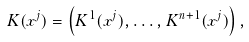<formula> <loc_0><loc_0><loc_500><loc_500>K ( x ^ { j } ) = \left ( K ^ { 1 } ( x ^ { j } ) , \dots , K ^ { n + 1 } ( x ^ { j } ) \right ) ,</formula> 